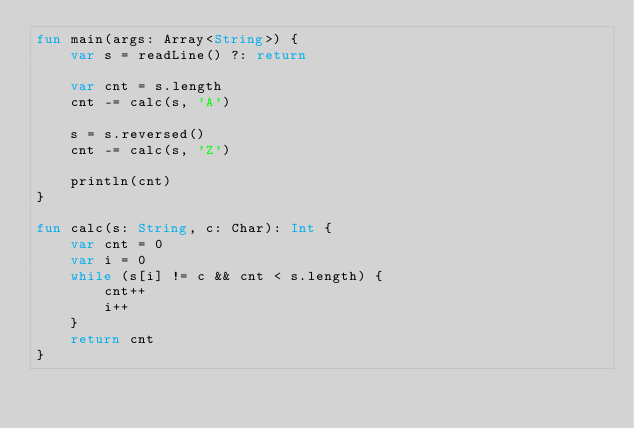Convert code to text. <code><loc_0><loc_0><loc_500><loc_500><_Kotlin_>fun main(args: Array<String>) {
	var s = readLine() ?: return

	var cnt = s.length
	cnt -= calc(s, 'A')

	s = s.reversed()
	cnt -= calc(s, 'Z')

	println(cnt)
}

fun calc(s: String, c: Char): Int {
	var cnt = 0
	var i = 0
	while (s[i] != c && cnt < s.length) {
		cnt++
		i++
	}
	return cnt
}
</code> 